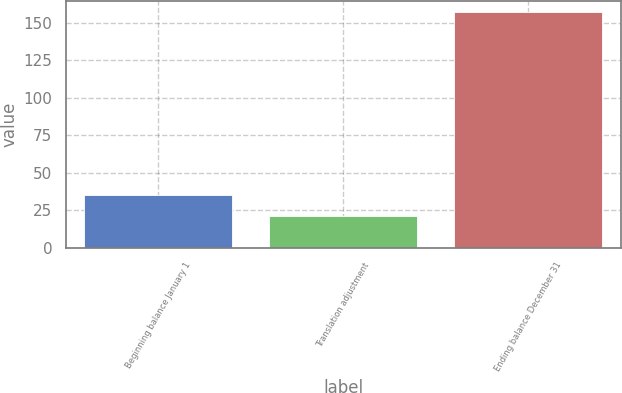Convert chart to OTSL. <chart><loc_0><loc_0><loc_500><loc_500><bar_chart><fcel>Beginning balance January 1<fcel>Translation adjustment<fcel>Ending balance December 31<nl><fcel>34.84<fcel>21.3<fcel>156.7<nl></chart> 